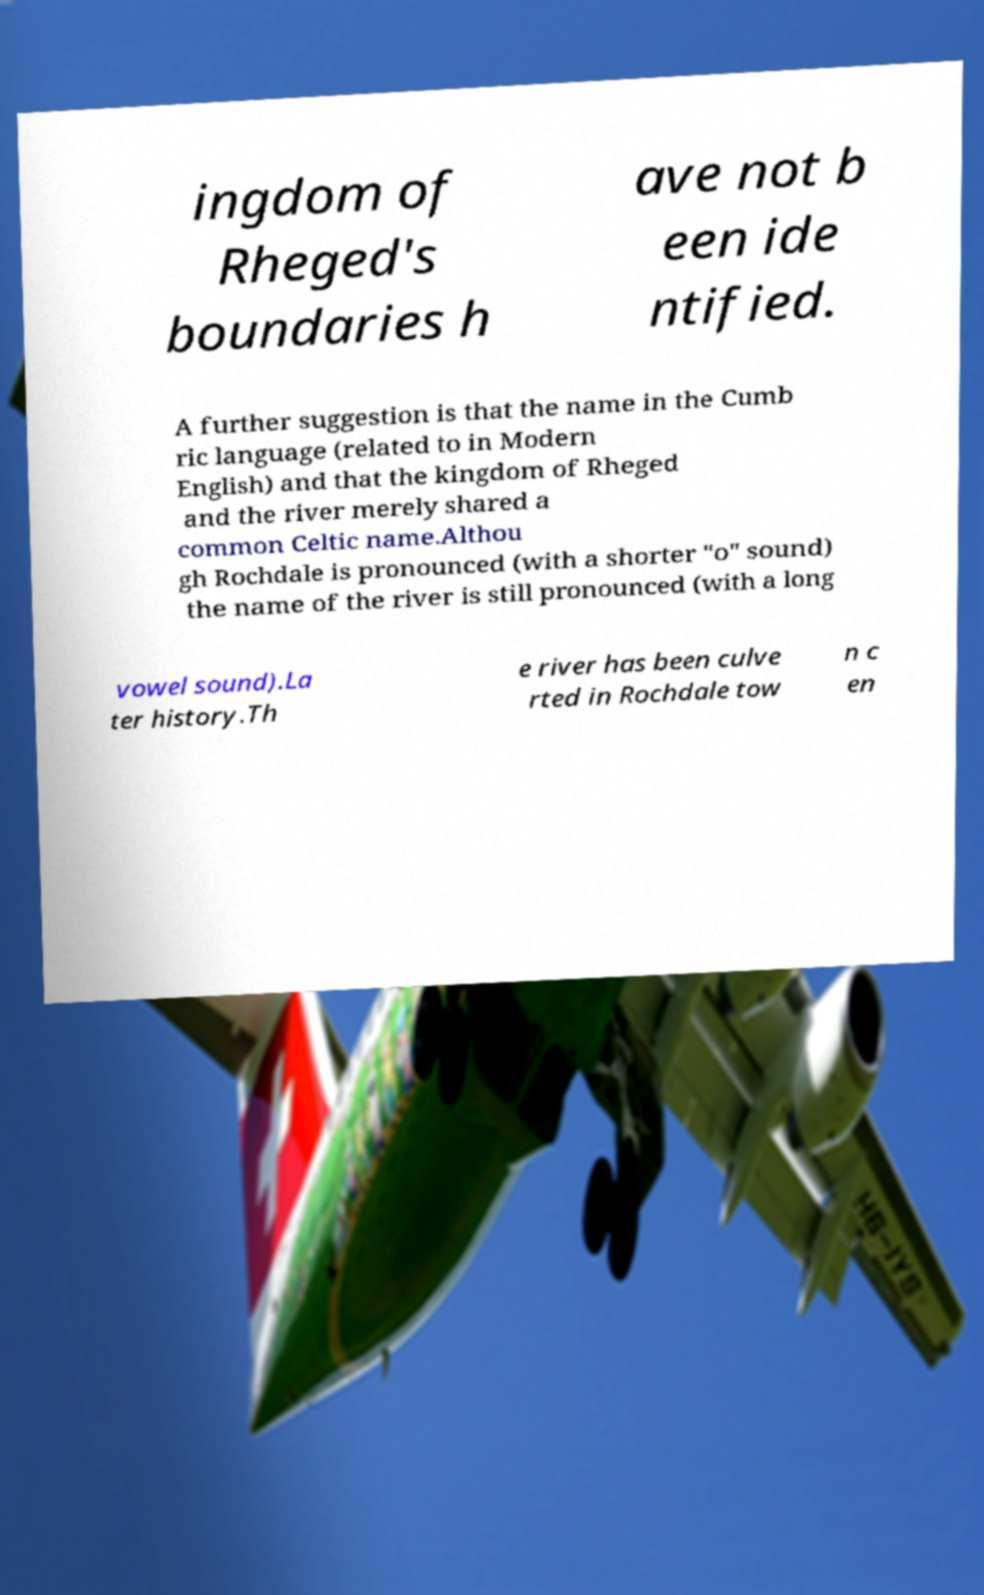Can you accurately transcribe the text from the provided image for me? ingdom of Rheged's boundaries h ave not b een ide ntified. A further suggestion is that the name in the Cumb ric language (related to in Modern English) and that the kingdom of Rheged and the river merely shared a common Celtic name.Althou gh Rochdale is pronounced (with a shorter "o" sound) the name of the river is still pronounced (with a long vowel sound).La ter history.Th e river has been culve rted in Rochdale tow n c en 